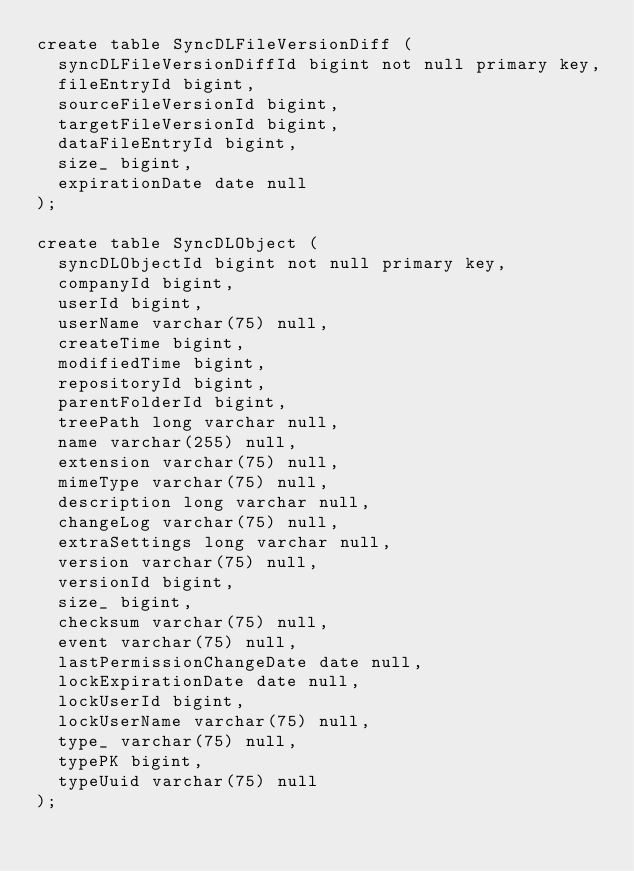<code> <loc_0><loc_0><loc_500><loc_500><_SQL_>create table SyncDLFileVersionDiff (
	syncDLFileVersionDiffId bigint not null primary key,
	fileEntryId bigint,
	sourceFileVersionId bigint,
	targetFileVersionId bigint,
	dataFileEntryId bigint,
	size_ bigint,
	expirationDate date null
);

create table SyncDLObject (
	syncDLObjectId bigint not null primary key,
	companyId bigint,
	userId bigint,
	userName varchar(75) null,
	createTime bigint,
	modifiedTime bigint,
	repositoryId bigint,
	parentFolderId bigint,
	treePath long varchar null,
	name varchar(255) null,
	extension varchar(75) null,
	mimeType varchar(75) null,
	description long varchar null,
	changeLog varchar(75) null,
	extraSettings long varchar null,
	version varchar(75) null,
	versionId bigint,
	size_ bigint,
	checksum varchar(75) null,
	event varchar(75) null,
	lastPermissionChangeDate date null,
	lockExpirationDate date null,
	lockUserId bigint,
	lockUserName varchar(75) null,
	type_ varchar(75) null,
	typePK bigint,
	typeUuid varchar(75) null
);
</code> 